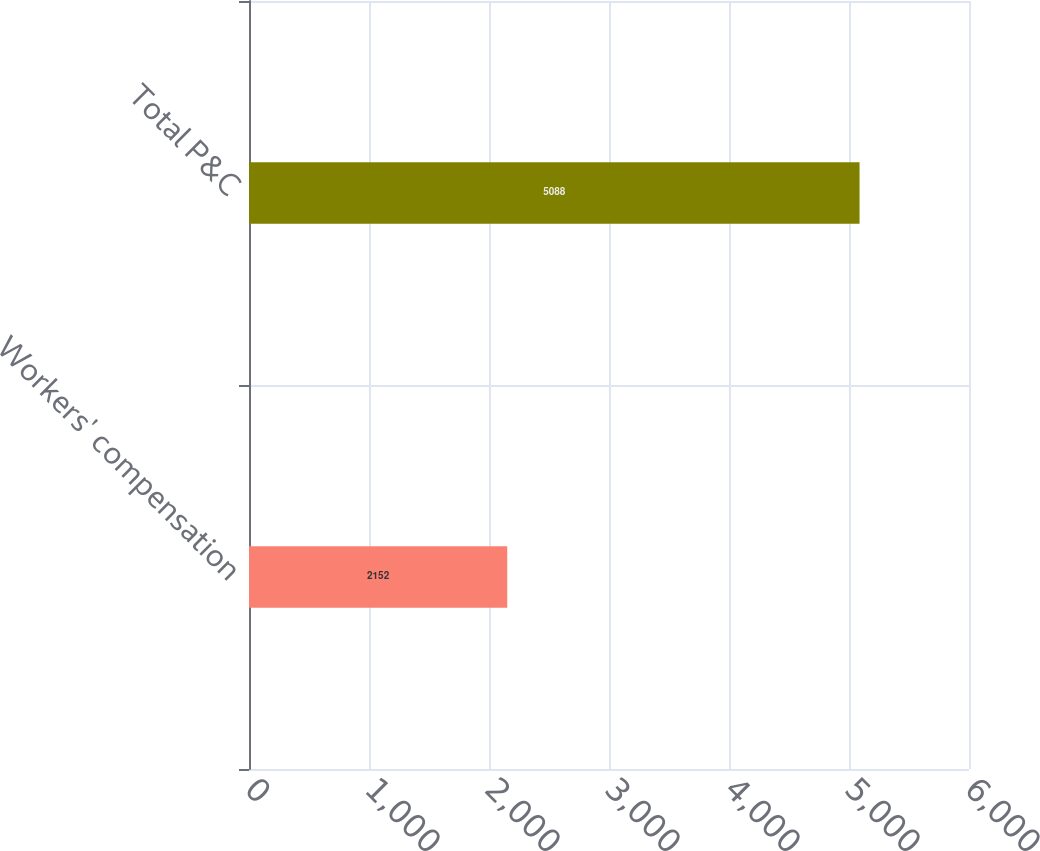Convert chart. <chart><loc_0><loc_0><loc_500><loc_500><bar_chart><fcel>Workers' compensation<fcel>Total P&C<nl><fcel>2152<fcel>5088<nl></chart> 